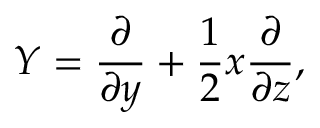<formula> <loc_0><loc_0><loc_500><loc_500>Y = { \frac { \partial } { \partial y } } + { \frac { 1 } { 2 } } x { \frac { \partial } { \partial z } } ,</formula> 